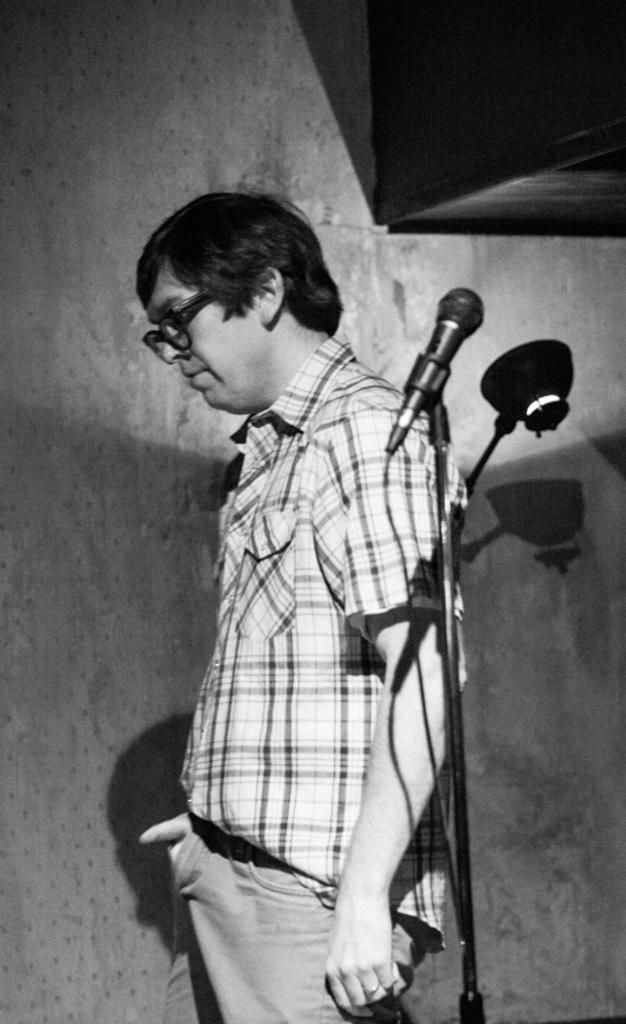Who is the main subject in the image? There is a man in the center of the image. What object is associated with the man in the image? A mic stand is present in the image. What can be seen in the background of the image? There is a wall in the background of the image. Where is the cupboard located in the image? A cupboard is present in the top right corner of the image. How many snakes are slithering across the floor in the image? There are no snakes present in the image. What type of quarter is visible on the man's shirt in the image? There is no quarter visible on the man's shirt in the image. 